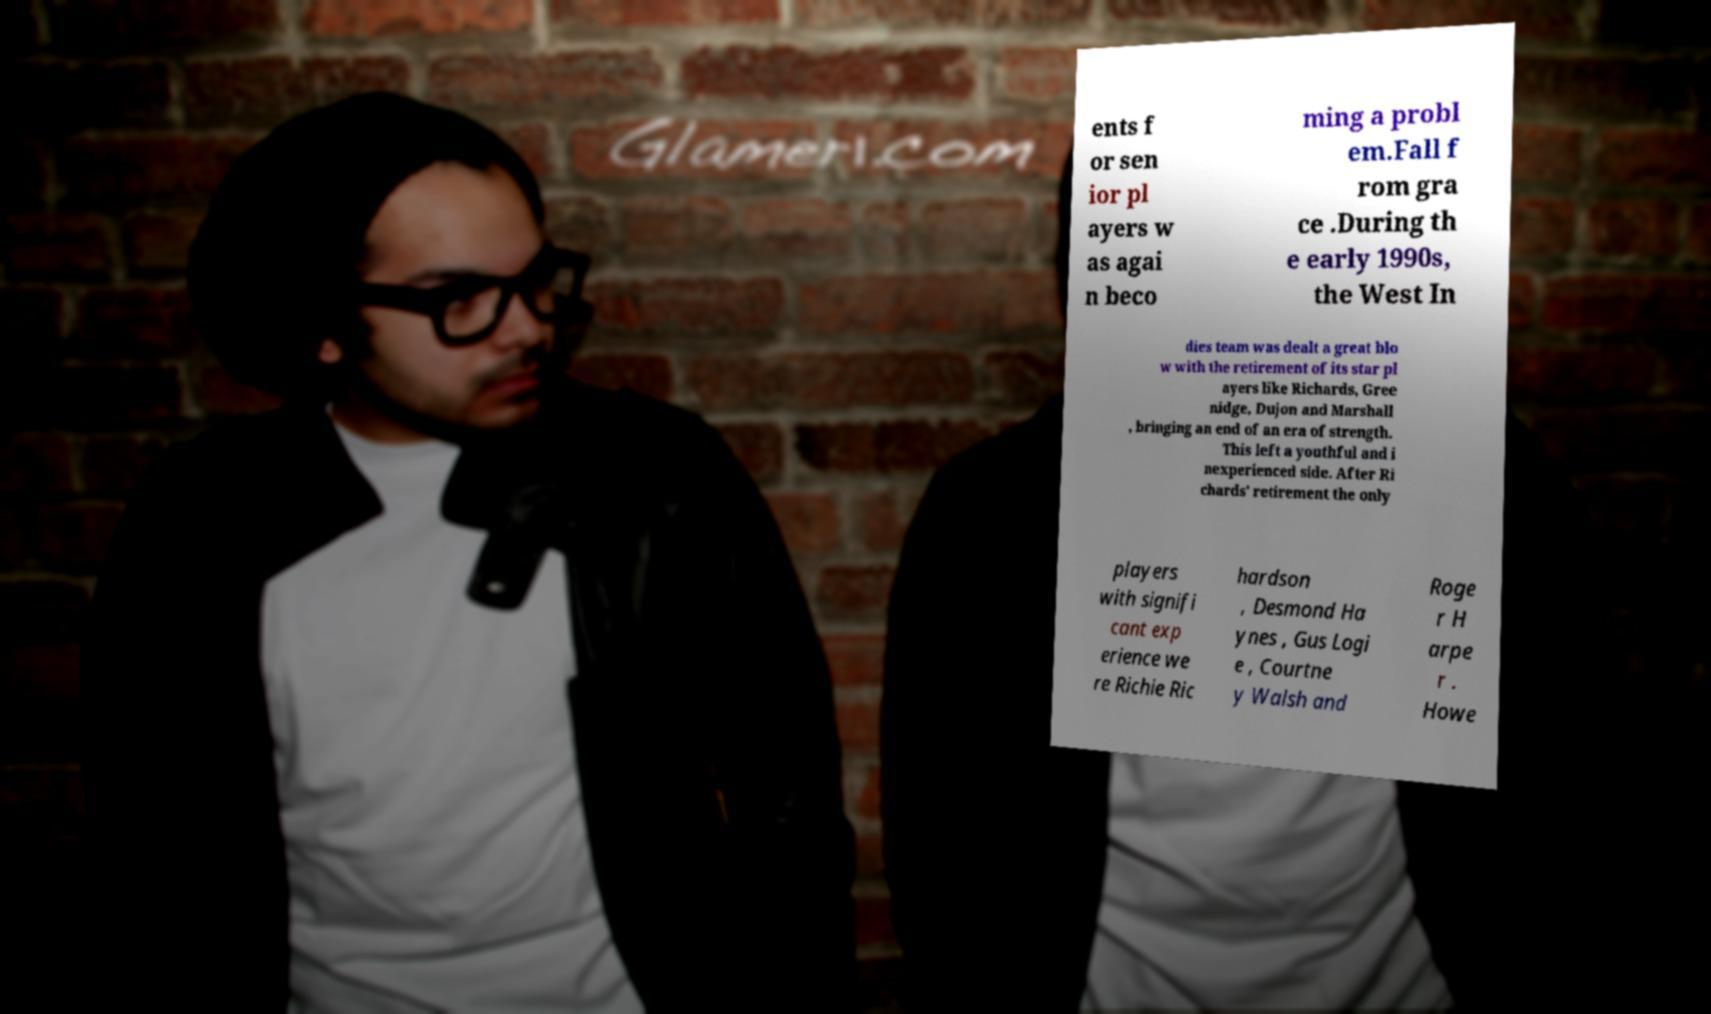I need the written content from this picture converted into text. Can you do that? ents f or sen ior pl ayers w as agai n beco ming a probl em.Fall f rom gra ce .During th e early 1990s, the West In dies team was dealt a great blo w with the retirement of its star pl ayers like Richards, Gree nidge, Dujon and Marshall , bringing an end of an era of strength. This left a youthful and i nexperienced side. After Ri chards' retirement the only players with signifi cant exp erience we re Richie Ric hardson , Desmond Ha ynes , Gus Logi e , Courtne y Walsh and Roge r H arpe r . Howe 